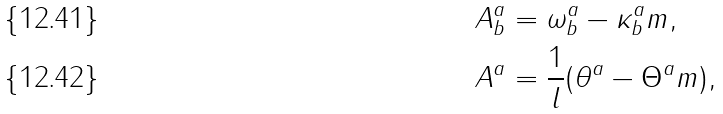Convert formula to latex. <formula><loc_0><loc_0><loc_500><loc_500>A _ { b } ^ { a } & = \omega _ { b } ^ { a } - \kappa _ { b } ^ { a } m , \\ A ^ { a } & = \frac { 1 } { l } ( \theta ^ { a } - \Theta ^ { a } m ) ,</formula> 